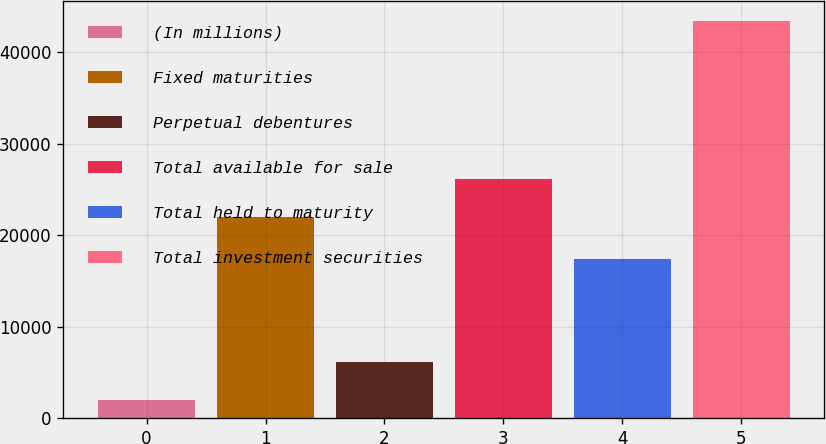Convert chart to OTSL. <chart><loc_0><loc_0><loc_500><loc_500><bar_chart><fcel>(In millions)<fcel>Fixed maturities<fcel>Perpetual debentures<fcel>Total available for sale<fcel>Total held to maturity<fcel>Total investment securities<nl><fcel>2006<fcel>22044<fcel>6151.2<fcel>26189.2<fcel>17454<fcel>43458<nl></chart> 